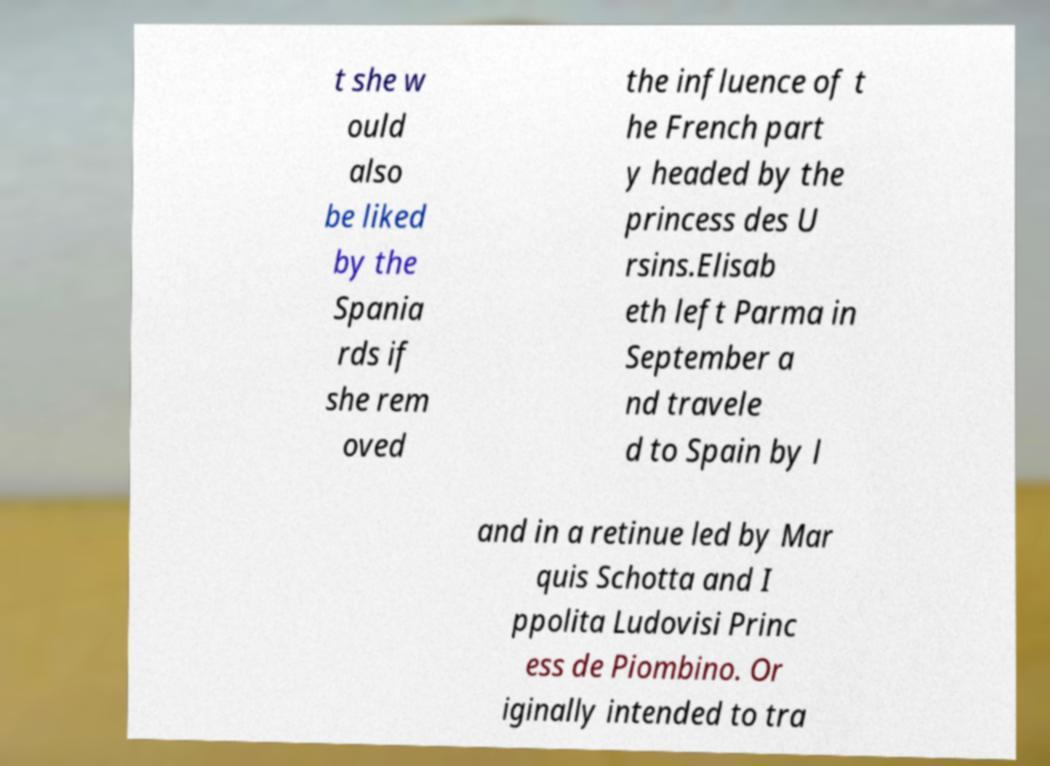Could you extract and type out the text from this image? t she w ould also be liked by the Spania rds if she rem oved the influence of t he French part y headed by the princess des U rsins.Elisab eth left Parma in September a nd travele d to Spain by l and in a retinue led by Mar quis Schotta and I ppolita Ludovisi Princ ess de Piombino. Or iginally intended to tra 